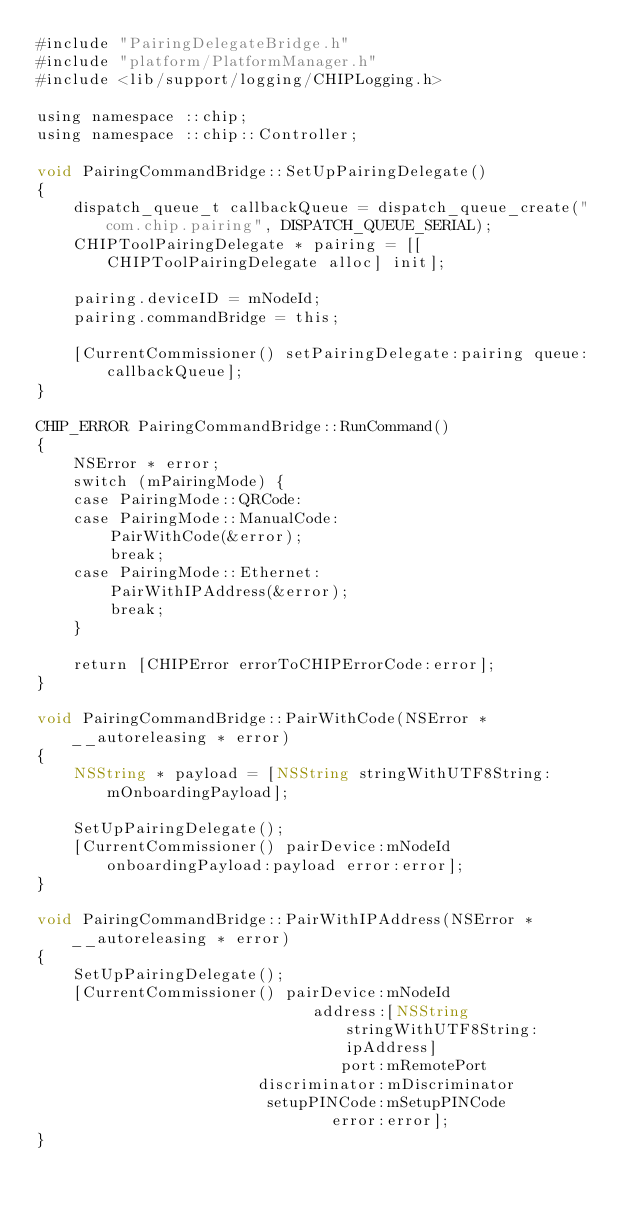<code> <loc_0><loc_0><loc_500><loc_500><_ObjectiveC_>#include "PairingDelegateBridge.h"
#include "platform/PlatformManager.h"
#include <lib/support/logging/CHIPLogging.h>

using namespace ::chip;
using namespace ::chip::Controller;

void PairingCommandBridge::SetUpPairingDelegate()
{
    dispatch_queue_t callbackQueue = dispatch_queue_create("com.chip.pairing", DISPATCH_QUEUE_SERIAL);
    CHIPToolPairingDelegate * pairing = [[CHIPToolPairingDelegate alloc] init];

    pairing.deviceID = mNodeId;
    pairing.commandBridge = this;

    [CurrentCommissioner() setPairingDelegate:pairing queue:callbackQueue];
}

CHIP_ERROR PairingCommandBridge::RunCommand()
{
    NSError * error;
    switch (mPairingMode) {
    case PairingMode::QRCode:
    case PairingMode::ManualCode:
        PairWithCode(&error);
        break;
    case PairingMode::Ethernet:
        PairWithIPAddress(&error);
        break;
    }

    return [CHIPError errorToCHIPErrorCode:error];
}

void PairingCommandBridge::PairWithCode(NSError * __autoreleasing * error)
{
    NSString * payload = [NSString stringWithUTF8String:mOnboardingPayload];

    SetUpPairingDelegate();
    [CurrentCommissioner() pairDevice:mNodeId onboardingPayload:payload error:error];
}

void PairingCommandBridge::PairWithIPAddress(NSError * __autoreleasing * error)
{
    SetUpPairingDelegate();
    [CurrentCommissioner() pairDevice:mNodeId
                              address:[NSString stringWithUTF8String:ipAddress]
                                 port:mRemotePort
                        discriminator:mDiscriminator
                         setupPINCode:mSetupPINCode
                                error:error];
}
</code> 